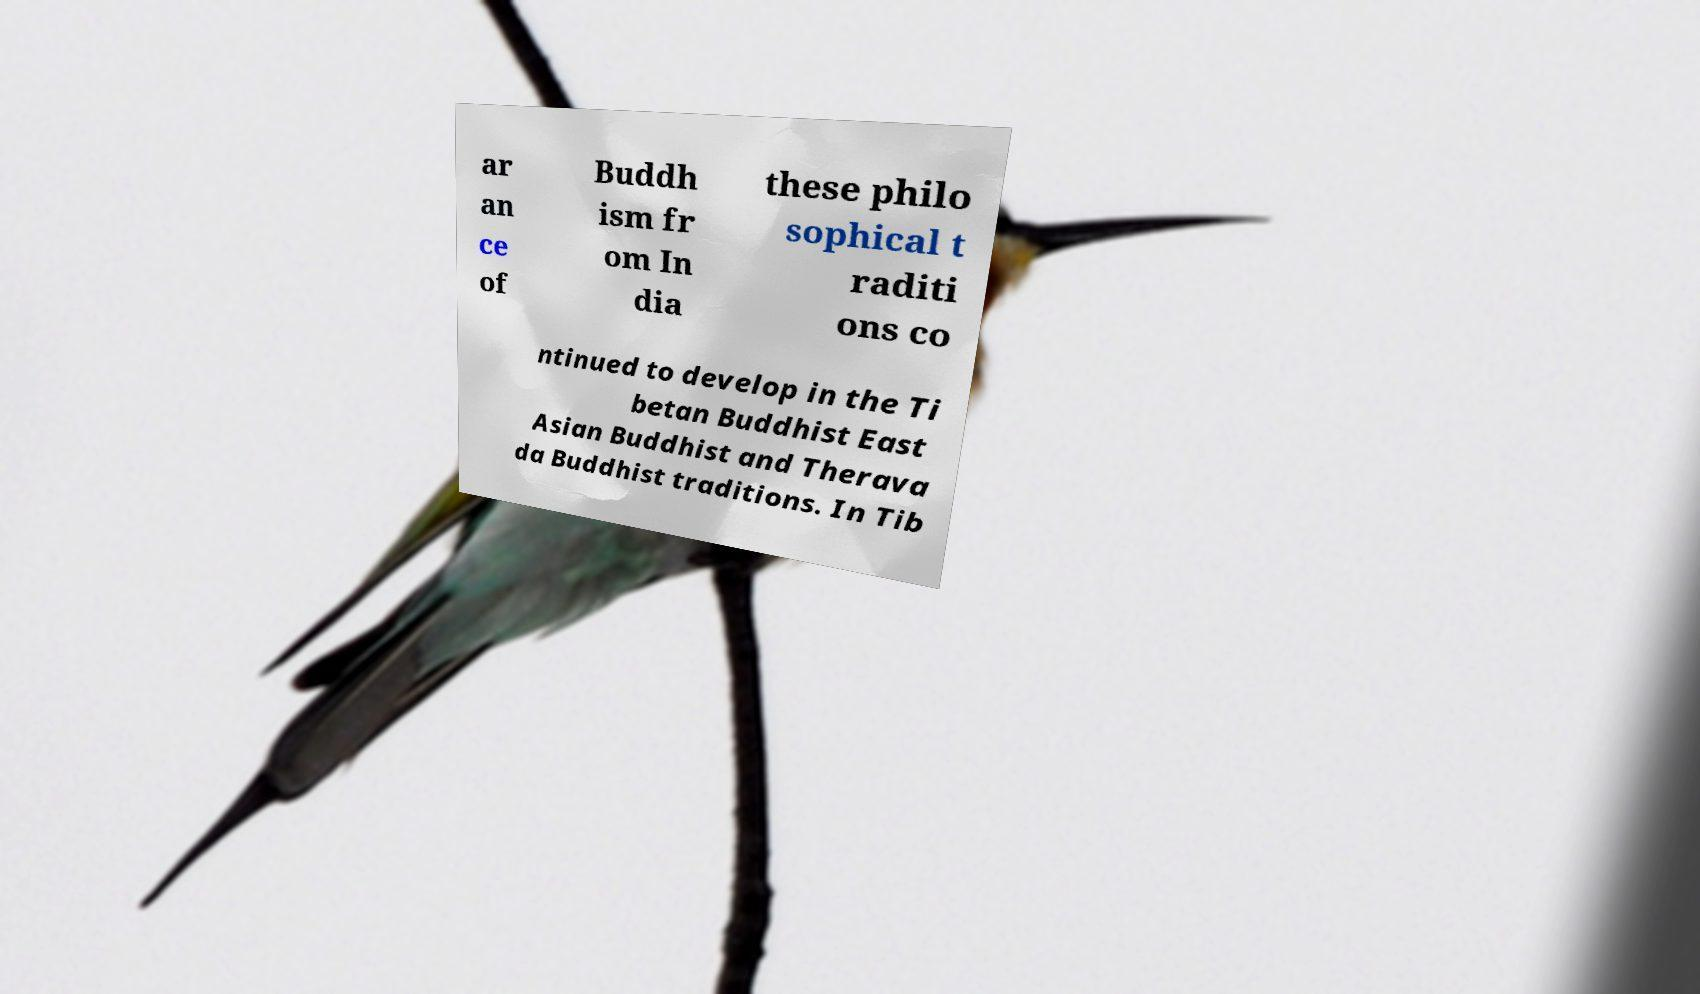Please read and relay the text visible in this image. What does it say? ar an ce of Buddh ism fr om In dia these philo sophical t raditi ons co ntinued to develop in the Ti betan Buddhist East Asian Buddhist and Therava da Buddhist traditions. In Tib 